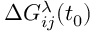Convert formula to latex. <formula><loc_0><loc_0><loc_500><loc_500>\Delta G _ { i j } ^ { \lambda } ( t _ { 0 } )</formula> 